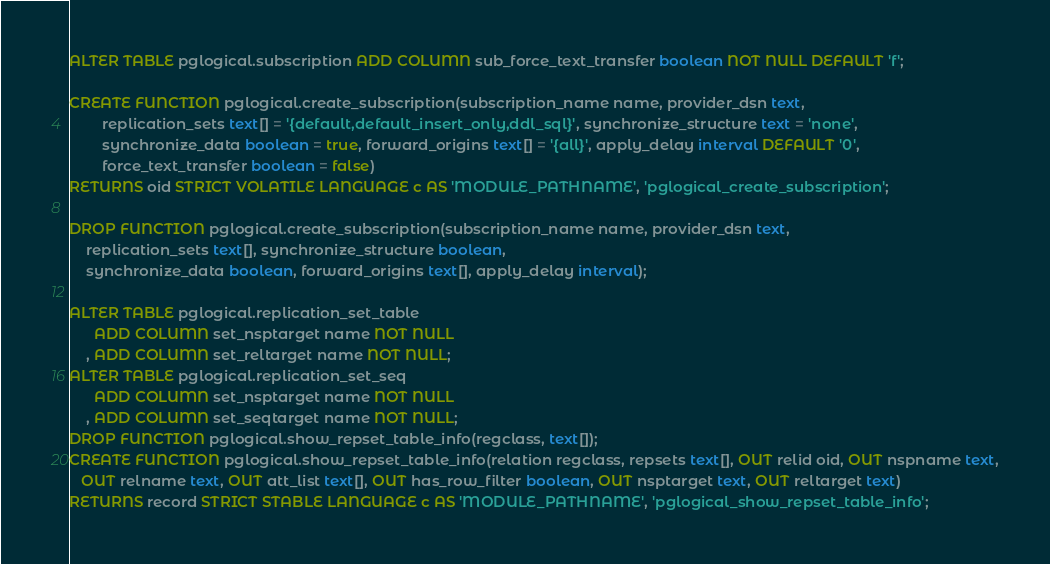Convert code to text. <code><loc_0><loc_0><loc_500><loc_500><_SQL_>ALTER TABLE pglogical.subscription ADD COLUMN sub_force_text_transfer boolean NOT NULL DEFAULT 'f';

CREATE FUNCTION pglogical.create_subscription(subscription_name name, provider_dsn text,
	    replication_sets text[] = '{default,default_insert_only,ddl_sql}', synchronize_structure text = 'none',
	    synchronize_data boolean = true, forward_origins text[] = '{all}', apply_delay interval DEFAULT '0',
	    force_text_transfer boolean = false)
RETURNS oid STRICT VOLATILE LANGUAGE c AS 'MODULE_PATHNAME', 'pglogical_create_subscription';

DROP FUNCTION pglogical.create_subscription(subscription_name name, provider_dsn text,
    replication_sets text[], synchronize_structure boolean,
    synchronize_data boolean, forward_origins text[], apply_delay interval);

ALTER TABLE pglogical.replication_set_table
      ADD COLUMN set_nsptarget name NOT NULL
    , ADD COLUMN set_reltarget name NOT NULL;
ALTER TABLE pglogical.replication_set_seq
      ADD COLUMN set_nsptarget name NOT NULL
    , ADD COLUMN set_seqtarget name NOT NULL;
DROP FUNCTION pglogical.show_repset_table_info(regclass, text[]);
CREATE FUNCTION pglogical.show_repset_table_info(relation regclass, repsets text[], OUT relid oid, OUT nspname text,
   OUT relname text, OUT att_list text[], OUT has_row_filter boolean, OUT nsptarget text, OUT reltarget text)
RETURNS record STRICT STABLE LANGUAGE c AS 'MODULE_PATHNAME', 'pglogical_show_repset_table_info';
</code> 